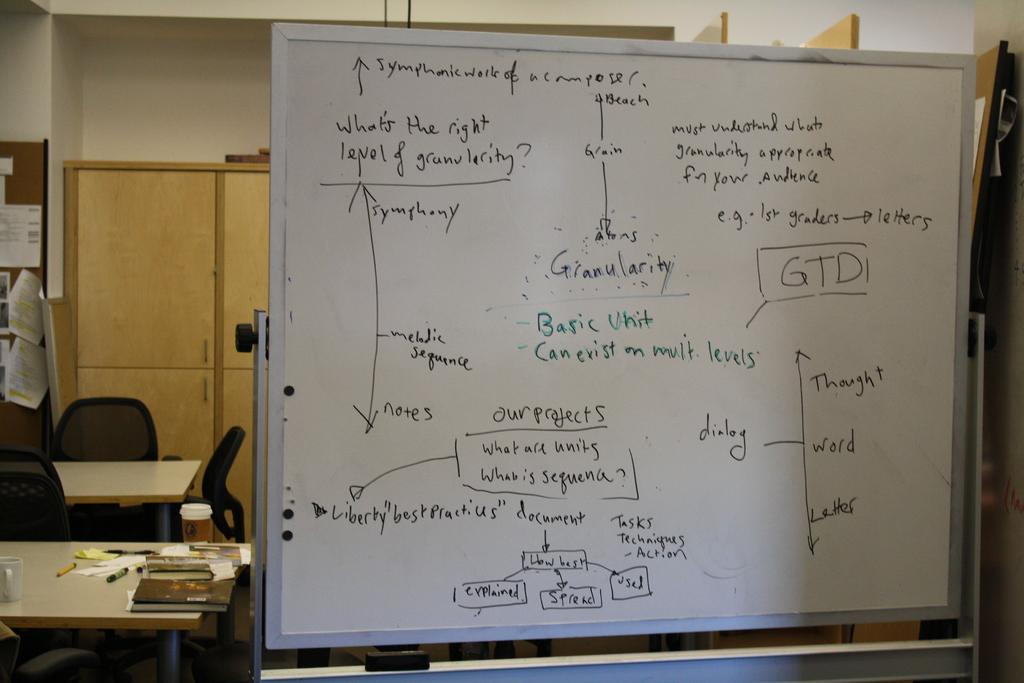What is the main object in the image? There is a whiteboard in the image. What is located near the whiteboard? There is a table in the image. What can be found on the table? There is a pen and a cup on the table. What is the seating arrangement in the image? There is a chair in the image. What is the surface for writing or drawing in the image? There is a desk in the image. What is placed on the desk? There is a paper on the desk. How many icicles are hanging from the whiteboard in the image? There are no icicles present in the image. What type of cushion is placed on the chair in the image? There is no cushion present on the chair in the image. 